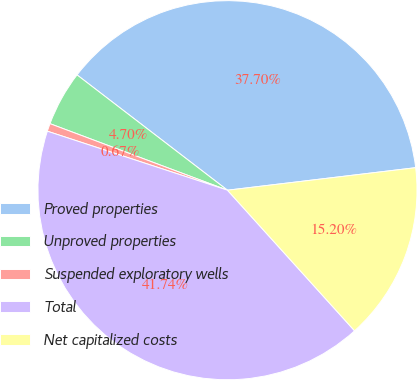<chart> <loc_0><loc_0><loc_500><loc_500><pie_chart><fcel>Proved properties<fcel>Unproved properties<fcel>Suspended exploratory wells<fcel>Total<fcel>Net capitalized costs<nl><fcel>37.7%<fcel>4.7%<fcel>0.67%<fcel>41.74%<fcel>15.2%<nl></chart> 